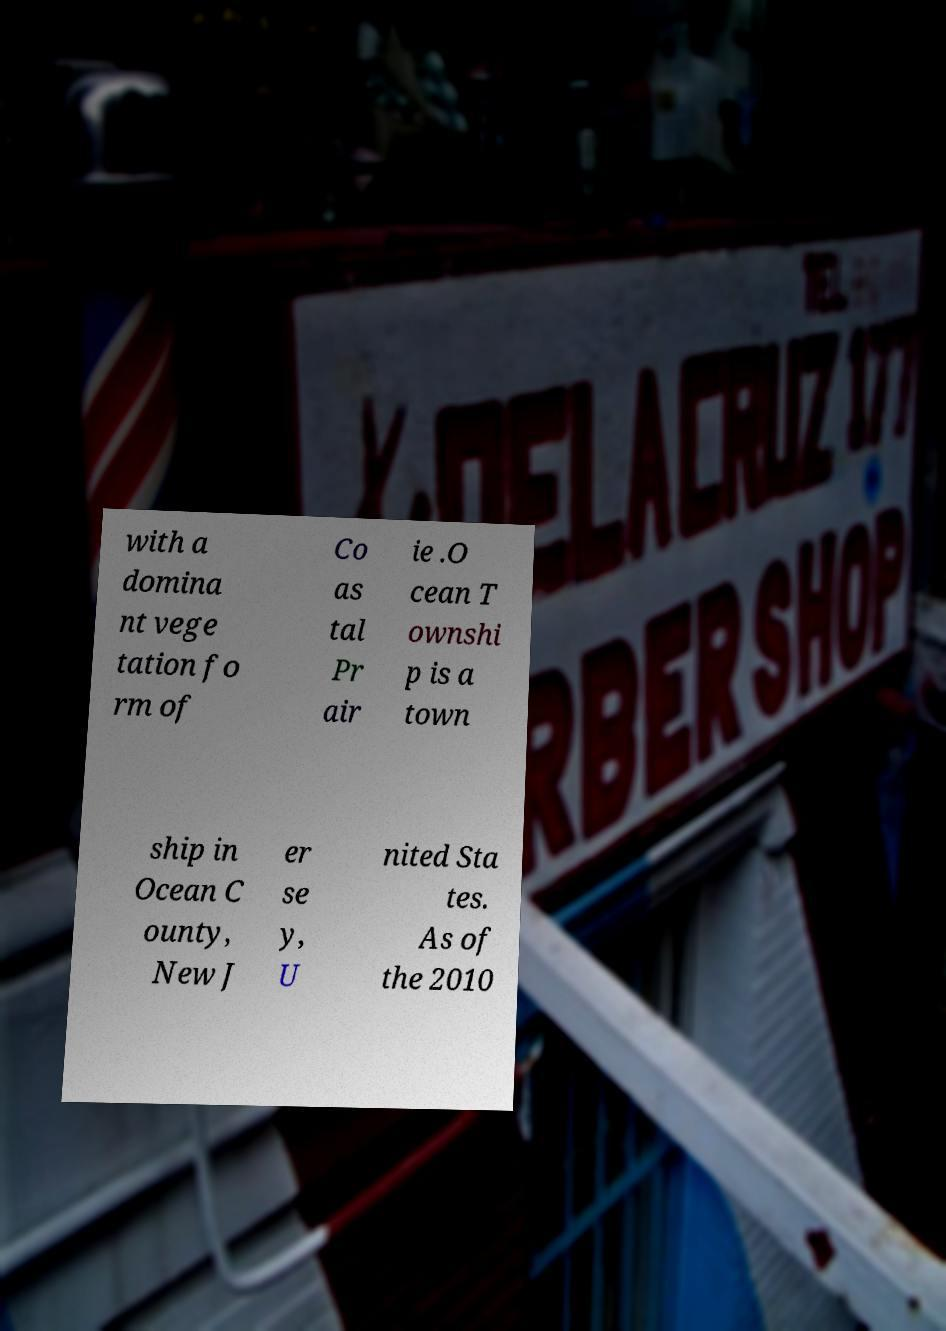Could you assist in decoding the text presented in this image and type it out clearly? with a domina nt vege tation fo rm of Co as tal Pr air ie .O cean T ownshi p is a town ship in Ocean C ounty, New J er se y, U nited Sta tes. As of the 2010 